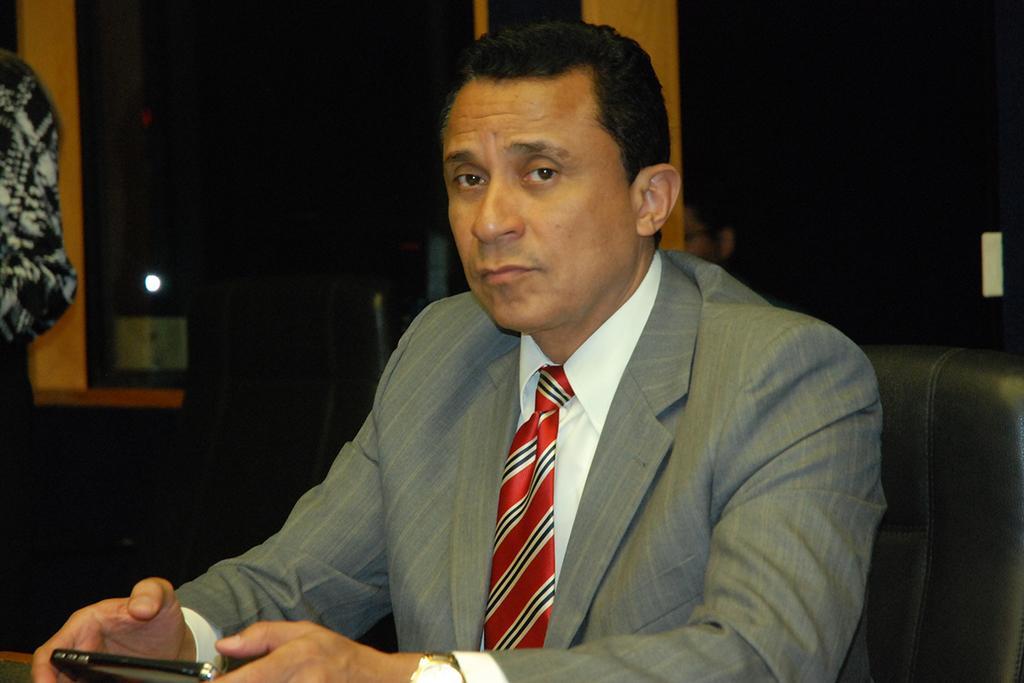Can you describe this image briefly? In this picture we can observe a person sitting in the black color chair. He is wearing grey color coat and a red color tie. On the left side there is a person standing. We can observe a chair. In the background there is a bottle placed on the desk. 